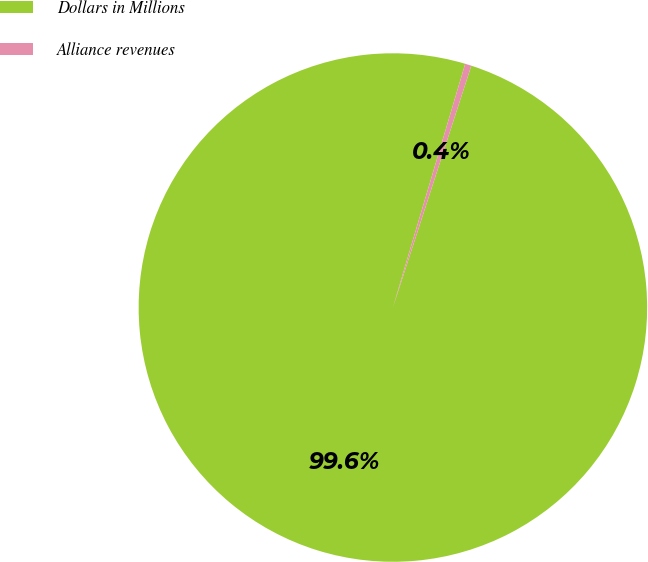Convert chart. <chart><loc_0><loc_0><loc_500><loc_500><pie_chart><fcel>Dollars in Millions<fcel>Alliance revenues<nl><fcel>99.6%<fcel>0.4%<nl></chart> 